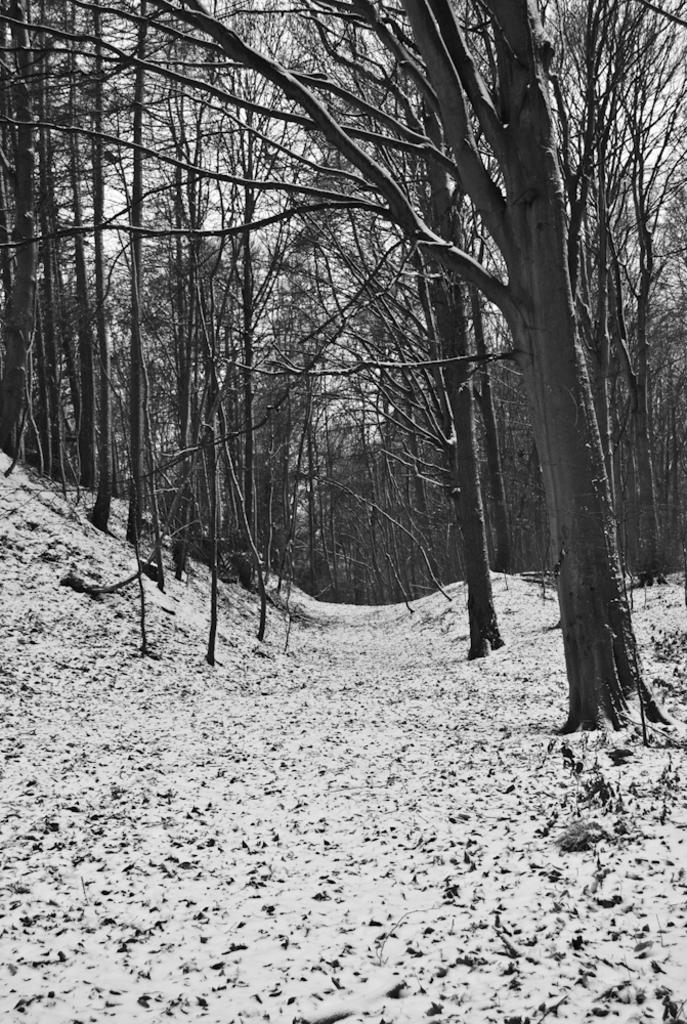What type of vegetation can be seen in the image? There are numerous trees in the image. What is the terrain like in the image? The location appears to be an icy landscape. What covers the ground in the image? The ground is covered with ice and snow. Is there a path or route visible in the image? Yes, there is a route visible between the trees. What type of thread is being used to sew the fear in the image? There is no thread or fear present in the image; it features an icy landscape with trees and a route. 